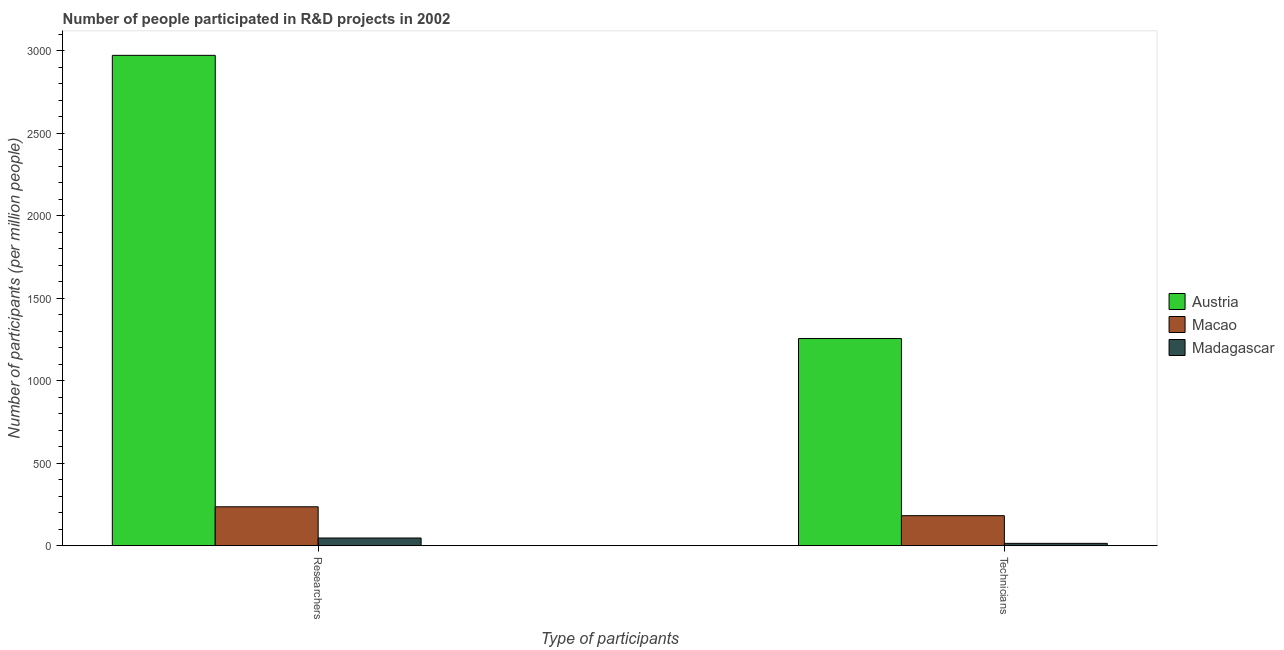How many bars are there on the 2nd tick from the left?
Your answer should be very brief. 3. How many bars are there on the 2nd tick from the right?
Ensure brevity in your answer.  3. What is the label of the 2nd group of bars from the left?
Provide a short and direct response. Technicians. What is the number of technicians in Madagascar?
Make the answer very short. 14.64. Across all countries, what is the maximum number of technicians?
Give a very brief answer. 1256.23. Across all countries, what is the minimum number of researchers?
Offer a very short reply. 47.08. In which country was the number of technicians minimum?
Offer a terse response. Madagascar. What is the total number of technicians in the graph?
Your answer should be very brief. 1453.45. What is the difference between the number of technicians in Austria and that in Madagascar?
Provide a short and direct response. 1241.59. What is the difference between the number of technicians in Madagascar and the number of researchers in Macao?
Provide a succinct answer. -221.75. What is the average number of technicians per country?
Keep it short and to the point. 484.48. What is the difference between the number of researchers and number of technicians in Madagascar?
Provide a succinct answer. 32.44. In how many countries, is the number of researchers greater than 300 ?
Provide a short and direct response. 1. What is the ratio of the number of researchers in Austria to that in Macao?
Keep it short and to the point. 12.58. Is the number of technicians in Macao less than that in Austria?
Offer a terse response. Yes. What does the 3rd bar from the left in Researchers represents?
Keep it short and to the point. Madagascar. What does the 3rd bar from the right in Technicians represents?
Your answer should be very brief. Austria. How many bars are there?
Provide a short and direct response. 6. Are all the bars in the graph horizontal?
Make the answer very short. No. How many countries are there in the graph?
Make the answer very short. 3. What is the difference between two consecutive major ticks on the Y-axis?
Provide a short and direct response. 500. Are the values on the major ticks of Y-axis written in scientific E-notation?
Your answer should be compact. No. Does the graph contain any zero values?
Provide a short and direct response. No. What is the title of the graph?
Give a very brief answer. Number of people participated in R&D projects in 2002. Does "Brunei Darussalam" appear as one of the legend labels in the graph?
Offer a terse response. No. What is the label or title of the X-axis?
Give a very brief answer. Type of participants. What is the label or title of the Y-axis?
Your answer should be very brief. Number of participants (per million people). What is the Number of participants (per million people) of Austria in Researchers?
Provide a short and direct response. 2972.89. What is the Number of participants (per million people) in Macao in Researchers?
Give a very brief answer. 236.39. What is the Number of participants (per million people) in Madagascar in Researchers?
Ensure brevity in your answer.  47.08. What is the Number of participants (per million people) of Austria in Technicians?
Your answer should be compact. 1256.23. What is the Number of participants (per million people) of Macao in Technicians?
Your answer should be compact. 182.58. What is the Number of participants (per million people) in Madagascar in Technicians?
Ensure brevity in your answer.  14.64. Across all Type of participants, what is the maximum Number of participants (per million people) in Austria?
Provide a succinct answer. 2972.89. Across all Type of participants, what is the maximum Number of participants (per million people) of Macao?
Make the answer very short. 236.39. Across all Type of participants, what is the maximum Number of participants (per million people) of Madagascar?
Offer a terse response. 47.08. Across all Type of participants, what is the minimum Number of participants (per million people) in Austria?
Your answer should be compact. 1256.23. Across all Type of participants, what is the minimum Number of participants (per million people) of Macao?
Provide a short and direct response. 182.58. Across all Type of participants, what is the minimum Number of participants (per million people) of Madagascar?
Your answer should be compact. 14.64. What is the total Number of participants (per million people) of Austria in the graph?
Give a very brief answer. 4229.12. What is the total Number of participants (per million people) of Macao in the graph?
Ensure brevity in your answer.  418.98. What is the total Number of participants (per million people) in Madagascar in the graph?
Keep it short and to the point. 61.72. What is the difference between the Number of participants (per million people) of Austria in Researchers and that in Technicians?
Your response must be concise. 1716.66. What is the difference between the Number of participants (per million people) of Macao in Researchers and that in Technicians?
Provide a short and direct response. 53.81. What is the difference between the Number of participants (per million people) of Madagascar in Researchers and that in Technicians?
Keep it short and to the point. 32.45. What is the difference between the Number of participants (per million people) in Austria in Researchers and the Number of participants (per million people) in Macao in Technicians?
Offer a terse response. 2790.3. What is the difference between the Number of participants (per million people) in Austria in Researchers and the Number of participants (per million people) in Madagascar in Technicians?
Offer a very short reply. 2958.25. What is the difference between the Number of participants (per million people) of Macao in Researchers and the Number of participants (per million people) of Madagascar in Technicians?
Keep it short and to the point. 221.75. What is the average Number of participants (per million people) in Austria per Type of participants?
Ensure brevity in your answer.  2114.56. What is the average Number of participants (per million people) in Macao per Type of participants?
Give a very brief answer. 209.49. What is the average Number of participants (per million people) of Madagascar per Type of participants?
Offer a very short reply. 30.86. What is the difference between the Number of participants (per million people) of Austria and Number of participants (per million people) of Macao in Researchers?
Offer a very short reply. 2736.5. What is the difference between the Number of participants (per million people) in Austria and Number of participants (per million people) in Madagascar in Researchers?
Provide a succinct answer. 2925.81. What is the difference between the Number of participants (per million people) of Macao and Number of participants (per million people) of Madagascar in Researchers?
Offer a terse response. 189.31. What is the difference between the Number of participants (per million people) in Austria and Number of participants (per million people) in Macao in Technicians?
Your response must be concise. 1073.64. What is the difference between the Number of participants (per million people) in Austria and Number of participants (per million people) in Madagascar in Technicians?
Offer a very short reply. 1241.59. What is the difference between the Number of participants (per million people) in Macao and Number of participants (per million people) in Madagascar in Technicians?
Make the answer very short. 167.95. What is the ratio of the Number of participants (per million people) of Austria in Researchers to that in Technicians?
Your answer should be very brief. 2.37. What is the ratio of the Number of participants (per million people) of Macao in Researchers to that in Technicians?
Keep it short and to the point. 1.29. What is the ratio of the Number of participants (per million people) in Madagascar in Researchers to that in Technicians?
Provide a short and direct response. 3.22. What is the difference between the highest and the second highest Number of participants (per million people) in Austria?
Provide a succinct answer. 1716.66. What is the difference between the highest and the second highest Number of participants (per million people) of Macao?
Give a very brief answer. 53.81. What is the difference between the highest and the second highest Number of participants (per million people) of Madagascar?
Your response must be concise. 32.45. What is the difference between the highest and the lowest Number of participants (per million people) in Austria?
Ensure brevity in your answer.  1716.66. What is the difference between the highest and the lowest Number of participants (per million people) of Macao?
Your answer should be very brief. 53.81. What is the difference between the highest and the lowest Number of participants (per million people) of Madagascar?
Ensure brevity in your answer.  32.45. 